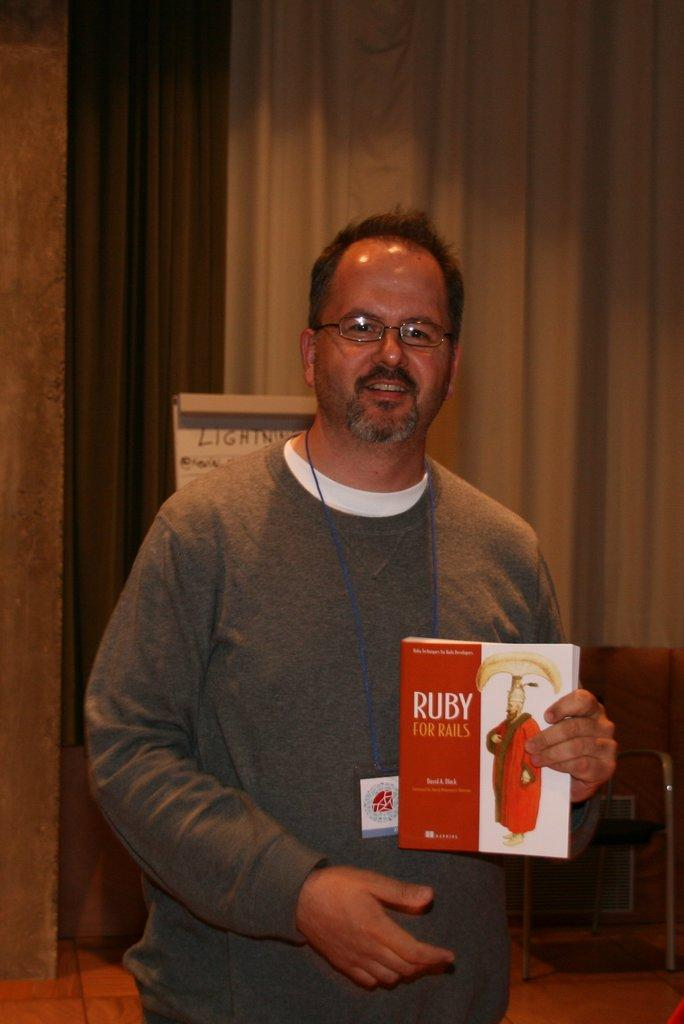<image>
Write a terse but informative summary of the picture. A man in a gray shirt that is holding a book called Ruby for Rails in his hands. 